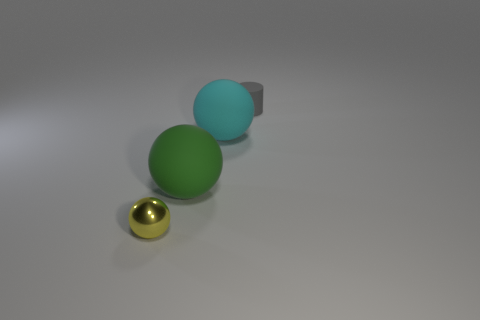There is a green thing; is it the same shape as the small object behind the small metal object?
Give a very brief answer. No. There is a tiny object left of the tiny object that is to the right of the small thing that is in front of the small gray matte thing; what shape is it?
Make the answer very short. Sphere. How many other objects are there of the same material as the yellow thing?
Provide a succinct answer. 0. How many objects are either things that are right of the cyan rubber thing or tiny metal things?
Make the answer very short. 2. The small thing in front of the tiny thing that is to the right of the yellow object is what shape?
Keep it short and to the point. Sphere. Do the thing that is in front of the big green rubber thing and the green thing have the same shape?
Ensure brevity in your answer.  Yes. There is a matte thing to the left of the cyan rubber object; what is its color?
Provide a short and direct response. Green. How many spheres are either large cyan things or big rubber things?
Your answer should be compact. 2. What size is the rubber thing right of the rubber sphere that is on the right side of the large green ball?
Your response must be concise. Small. What number of large cyan rubber spheres are left of the tiny gray thing?
Your answer should be compact. 1. 